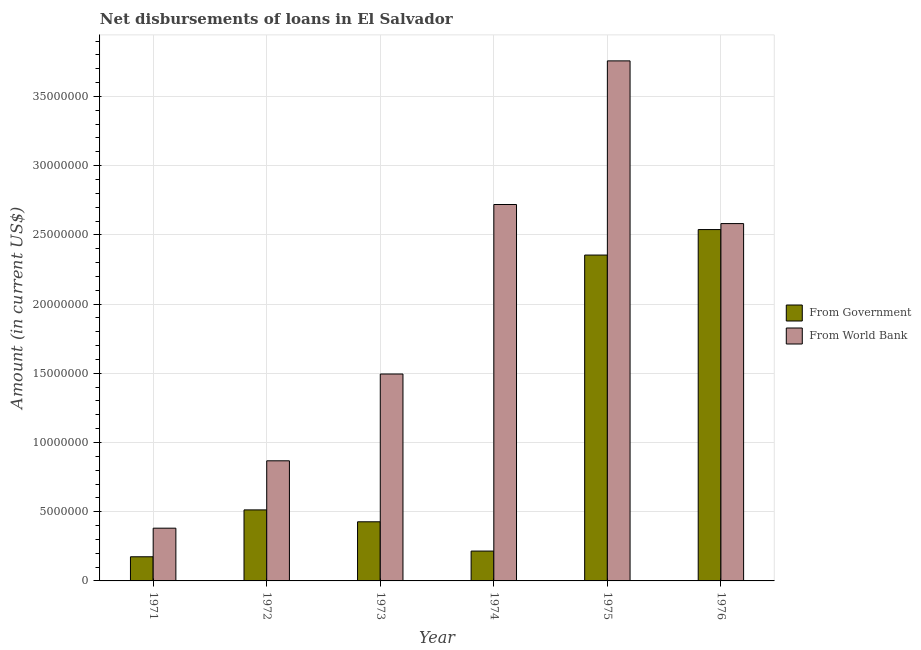How many groups of bars are there?
Offer a very short reply. 6. Are the number of bars per tick equal to the number of legend labels?
Provide a short and direct response. Yes. Are the number of bars on each tick of the X-axis equal?
Offer a terse response. Yes. What is the label of the 6th group of bars from the left?
Ensure brevity in your answer.  1976. What is the net disbursements of loan from government in 1974?
Offer a very short reply. 2.16e+06. Across all years, what is the maximum net disbursements of loan from world bank?
Give a very brief answer. 3.76e+07. Across all years, what is the minimum net disbursements of loan from world bank?
Your answer should be compact. 3.81e+06. In which year was the net disbursements of loan from government maximum?
Give a very brief answer. 1976. What is the total net disbursements of loan from government in the graph?
Give a very brief answer. 6.22e+07. What is the difference between the net disbursements of loan from world bank in 1972 and that in 1975?
Offer a terse response. -2.89e+07. What is the difference between the net disbursements of loan from world bank in 1971 and the net disbursements of loan from government in 1972?
Ensure brevity in your answer.  -4.87e+06. What is the average net disbursements of loan from government per year?
Your answer should be very brief. 1.04e+07. In how many years, is the net disbursements of loan from government greater than 7000000 US$?
Offer a very short reply. 2. What is the ratio of the net disbursements of loan from government in 1975 to that in 1976?
Provide a short and direct response. 0.93. Is the difference between the net disbursements of loan from government in 1974 and 1975 greater than the difference between the net disbursements of loan from world bank in 1974 and 1975?
Keep it short and to the point. No. What is the difference between the highest and the second highest net disbursements of loan from world bank?
Give a very brief answer. 1.04e+07. What is the difference between the highest and the lowest net disbursements of loan from government?
Provide a short and direct response. 2.36e+07. Is the sum of the net disbursements of loan from government in 1973 and 1975 greater than the maximum net disbursements of loan from world bank across all years?
Your answer should be very brief. Yes. What does the 1st bar from the left in 1976 represents?
Provide a succinct answer. From Government. What does the 2nd bar from the right in 1972 represents?
Keep it short and to the point. From Government. How many bars are there?
Keep it short and to the point. 12. Are all the bars in the graph horizontal?
Your answer should be very brief. No. Are the values on the major ticks of Y-axis written in scientific E-notation?
Offer a terse response. No. Does the graph contain any zero values?
Make the answer very short. No. Does the graph contain grids?
Your response must be concise. Yes. How many legend labels are there?
Provide a succinct answer. 2. What is the title of the graph?
Your answer should be compact. Net disbursements of loans in El Salvador. What is the label or title of the X-axis?
Your answer should be compact. Year. What is the Amount (in current US$) of From Government in 1971?
Provide a succinct answer. 1.74e+06. What is the Amount (in current US$) in From World Bank in 1971?
Offer a terse response. 3.81e+06. What is the Amount (in current US$) of From Government in 1972?
Your answer should be compact. 5.13e+06. What is the Amount (in current US$) of From World Bank in 1972?
Keep it short and to the point. 8.68e+06. What is the Amount (in current US$) of From Government in 1973?
Make the answer very short. 4.27e+06. What is the Amount (in current US$) of From World Bank in 1973?
Offer a very short reply. 1.49e+07. What is the Amount (in current US$) in From Government in 1974?
Your answer should be compact. 2.16e+06. What is the Amount (in current US$) in From World Bank in 1974?
Your answer should be compact. 2.72e+07. What is the Amount (in current US$) in From Government in 1975?
Your response must be concise. 2.35e+07. What is the Amount (in current US$) in From World Bank in 1975?
Ensure brevity in your answer.  3.76e+07. What is the Amount (in current US$) of From Government in 1976?
Make the answer very short. 2.54e+07. What is the Amount (in current US$) in From World Bank in 1976?
Keep it short and to the point. 2.58e+07. Across all years, what is the maximum Amount (in current US$) in From Government?
Your answer should be compact. 2.54e+07. Across all years, what is the maximum Amount (in current US$) in From World Bank?
Your answer should be very brief. 3.76e+07. Across all years, what is the minimum Amount (in current US$) in From Government?
Your answer should be compact. 1.74e+06. Across all years, what is the minimum Amount (in current US$) of From World Bank?
Make the answer very short. 3.81e+06. What is the total Amount (in current US$) in From Government in the graph?
Give a very brief answer. 6.22e+07. What is the total Amount (in current US$) of From World Bank in the graph?
Your response must be concise. 1.18e+08. What is the difference between the Amount (in current US$) in From Government in 1971 and that in 1972?
Provide a succinct answer. -3.39e+06. What is the difference between the Amount (in current US$) in From World Bank in 1971 and that in 1972?
Keep it short and to the point. -4.87e+06. What is the difference between the Amount (in current US$) in From Government in 1971 and that in 1973?
Your answer should be compact. -2.53e+06. What is the difference between the Amount (in current US$) in From World Bank in 1971 and that in 1973?
Ensure brevity in your answer.  -1.11e+07. What is the difference between the Amount (in current US$) of From Government in 1971 and that in 1974?
Ensure brevity in your answer.  -4.11e+05. What is the difference between the Amount (in current US$) of From World Bank in 1971 and that in 1974?
Make the answer very short. -2.34e+07. What is the difference between the Amount (in current US$) of From Government in 1971 and that in 1975?
Make the answer very short. -2.18e+07. What is the difference between the Amount (in current US$) in From World Bank in 1971 and that in 1975?
Make the answer very short. -3.38e+07. What is the difference between the Amount (in current US$) in From Government in 1971 and that in 1976?
Your answer should be very brief. -2.36e+07. What is the difference between the Amount (in current US$) of From World Bank in 1971 and that in 1976?
Give a very brief answer. -2.20e+07. What is the difference between the Amount (in current US$) in From Government in 1972 and that in 1973?
Provide a succinct answer. 8.59e+05. What is the difference between the Amount (in current US$) in From World Bank in 1972 and that in 1973?
Offer a very short reply. -6.27e+06. What is the difference between the Amount (in current US$) in From Government in 1972 and that in 1974?
Keep it short and to the point. 2.98e+06. What is the difference between the Amount (in current US$) in From World Bank in 1972 and that in 1974?
Give a very brief answer. -1.85e+07. What is the difference between the Amount (in current US$) in From Government in 1972 and that in 1975?
Keep it short and to the point. -1.84e+07. What is the difference between the Amount (in current US$) of From World Bank in 1972 and that in 1975?
Provide a short and direct response. -2.89e+07. What is the difference between the Amount (in current US$) in From Government in 1972 and that in 1976?
Your answer should be compact. -2.03e+07. What is the difference between the Amount (in current US$) in From World Bank in 1972 and that in 1976?
Ensure brevity in your answer.  -1.71e+07. What is the difference between the Amount (in current US$) of From Government in 1973 and that in 1974?
Keep it short and to the point. 2.12e+06. What is the difference between the Amount (in current US$) of From World Bank in 1973 and that in 1974?
Your response must be concise. -1.22e+07. What is the difference between the Amount (in current US$) of From Government in 1973 and that in 1975?
Offer a very short reply. -1.93e+07. What is the difference between the Amount (in current US$) of From World Bank in 1973 and that in 1975?
Your answer should be very brief. -2.26e+07. What is the difference between the Amount (in current US$) in From Government in 1973 and that in 1976?
Give a very brief answer. -2.11e+07. What is the difference between the Amount (in current US$) in From World Bank in 1973 and that in 1976?
Keep it short and to the point. -1.09e+07. What is the difference between the Amount (in current US$) in From Government in 1974 and that in 1975?
Keep it short and to the point. -2.14e+07. What is the difference between the Amount (in current US$) of From World Bank in 1974 and that in 1975?
Your response must be concise. -1.04e+07. What is the difference between the Amount (in current US$) of From Government in 1974 and that in 1976?
Give a very brief answer. -2.32e+07. What is the difference between the Amount (in current US$) in From World Bank in 1974 and that in 1976?
Offer a very short reply. 1.38e+06. What is the difference between the Amount (in current US$) of From Government in 1975 and that in 1976?
Give a very brief answer. -1.84e+06. What is the difference between the Amount (in current US$) of From World Bank in 1975 and that in 1976?
Keep it short and to the point. 1.18e+07. What is the difference between the Amount (in current US$) in From Government in 1971 and the Amount (in current US$) in From World Bank in 1972?
Give a very brief answer. -6.93e+06. What is the difference between the Amount (in current US$) of From Government in 1971 and the Amount (in current US$) of From World Bank in 1973?
Your response must be concise. -1.32e+07. What is the difference between the Amount (in current US$) of From Government in 1971 and the Amount (in current US$) of From World Bank in 1974?
Provide a succinct answer. -2.54e+07. What is the difference between the Amount (in current US$) in From Government in 1971 and the Amount (in current US$) in From World Bank in 1975?
Offer a terse response. -3.58e+07. What is the difference between the Amount (in current US$) in From Government in 1971 and the Amount (in current US$) in From World Bank in 1976?
Keep it short and to the point. -2.41e+07. What is the difference between the Amount (in current US$) of From Government in 1972 and the Amount (in current US$) of From World Bank in 1973?
Give a very brief answer. -9.82e+06. What is the difference between the Amount (in current US$) of From Government in 1972 and the Amount (in current US$) of From World Bank in 1974?
Ensure brevity in your answer.  -2.21e+07. What is the difference between the Amount (in current US$) in From Government in 1972 and the Amount (in current US$) in From World Bank in 1975?
Keep it short and to the point. -3.24e+07. What is the difference between the Amount (in current US$) of From Government in 1972 and the Amount (in current US$) of From World Bank in 1976?
Your response must be concise. -2.07e+07. What is the difference between the Amount (in current US$) of From Government in 1973 and the Amount (in current US$) of From World Bank in 1974?
Your response must be concise. -2.29e+07. What is the difference between the Amount (in current US$) in From Government in 1973 and the Amount (in current US$) in From World Bank in 1975?
Give a very brief answer. -3.33e+07. What is the difference between the Amount (in current US$) in From Government in 1973 and the Amount (in current US$) in From World Bank in 1976?
Provide a short and direct response. -2.15e+07. What is the difference between the Amount (in current US$) of From Government in 1974 and the Amount (in current US$) of From World Bank in 1975?
Give a very brief answer. -3.54e+07. What is the difference between the Amount (in current US$) in From Government in 1974 and the Amount (in current US$) in From World Bank in 1976?
Your response must be concise. -2.37e+07. What is the difference between the Amount (in current US$) of From Government in 1975 and the Amount (in current US$) of From World Bank in 1976?
Keep it short and to the point. -2.27e+06. What is the average Amount (in current US$) of From Government per year?
Give a very brief answer. 1.04e+07. What is the average Amount (in current US$) in From World Bank per year?
Your response must be concise. 1.97e+07. In the year 1971, what is the difference between the Amount (in current US$) in From Government and Amount (in current US$) in From World Bank?
Give a very brief answer. -2.06e+06. In the year 1972, what is the difference between the Amount (in current US$) of From Government and Amount (in current US$) of From World Bank?
Offer a very short reply. -3.55e+06. In the year 1973, what is the difference between the Amount (in current US$) of From Government and Amount (in current US$) of From World Bank?
Offer a terse response. -1.07e+07. In the year 1974, what is the difference between the Amount (in current US$) of From Government and Amount (in current US$) of From World Bank?
Your answer should be compact. -2.50e+07. In the year 1975, what is the difference between the Amount (in current US$) in From Government and Amount (in current US$) in From World Bank?
Your answer should be compact. -1.40e+07. In the year 1976, what is the difference between the Amount (in current US$) in From Government and Amount (in current US$) in From World Bank?
Give a very brief answer. -4.33e+05. What is the ratio of the Amount (in current US$) in From Government in 1971 to that in 1972?
Offer a very short reply. 0.34. What is the ratio of the Amount (in current US$) in From World Bank in 1971 to that in 1972?
Offer a terse response. 0.44. What is the ratio of the Amount (in current US$) in From Government in 1971 to that in 1973?
Give a very brief answer. 0.41. What is the ratio of the Amount (in current US$) of From World Bank in 1971 to that in 1973?
Provide a succinct answer. 0.25. What is the ratio of the Amount (in current US$) of From Government in 1971 to that in 1974?
Offer a very short reply. 0.81. What is the ratio of the Amount (in current US$) in From World Bank in 1971 to that in 1974?
Make the answer very short. 0.14. What is the ratio of the Amount (in current US$) in From Government in 1971 to that in 1975?
Provide a short and direct response. 0.07. What is the ratio of the Amount (in current US$) of From World Bank in 1971 to that in 1975?
Provide a succinct answer. 0.1. What is the ratio of the Amount (in current US$) in From Government in 1971 to that in 1976?
Your response must be concise. 0.07. What is the ratio of the Amount (in current US$) of From World Bank in 1971 to that in 1976?
Make the answer very short. 0.15. What is the ratio of the Amount (in current US$) in From Government in 1972 to that in 1973?
Make the answer very short. 1.2. What is the ratio of the Amount (in current US$) of From World Bank in 1972 to that in 1973?
Provide a succinct answer. 0.58. What is the ratio of the Amount (in current US$) in From Government in 1972 to that in 1974?
Offer a terse response. 2.38. What is the ratio of the Amount (in current US$) of From World Bank in 1972 to that in 1974?
Offer a very short reply. 0.32. What is the ratio of the Amount (in current US$) in From Government in 1972 to that in 1975?
Offer a very short reply. 0.22. What is the ratio of the Amount (in current US$) in From World Bank in 1972 to that in 1975?
Offer a terse response. 0.23. What is the ratio of the Amount (in current US$) in From Government in 1972 to that in 1976?
Give a very brief answer. 0.2. What is the ratio of the Amount (in current US$) of From World Bank in 1972 to that in 1976?
Your answer should be compact. 0.34. What is the ratio of the Amount (in current US$) of From Government in 1973 to that in 1974?
Provide a short and direct response. 1.98. What is the ratio of the Amount (in current US$) in From World Bank in 1973 to that in 1974?
Offer a terse response. 0.55. What is the ratio of the Amount (in current US$) of From Government in 1973 to that in 1975?
Offer a very short reply. 0.18. What is the ratio of the Amount (in current US$) of From World Bank in 1973 to that in 1975?
Provide a succinct answer. 0.4. What is the ratio of the Amount (in current US$) in From Government in 1973 to that in 1976?
Provide a succinct answer. 0.17. What is the ratio of the Amount (in current US$) in From World Bank in 1973 to that in 1976?
Make the answer very short. 0.58. What is the ratio of the Amount (in current US$) in From Government in 1974 to that in 1975?
Your answer should be very brief. 0.09. What is the ratio of the Amount (in current US$) of From World Bank in 1974 to that in 1975?
Provide a short and direct response. 0.72. What is the ratio of the Amount (in current US$) in From Government in 1974 to that in 1976?
Your answer should be compact. 0.08. What is the ratio of the Amount (in current US$) in From World Bank in 1974 to that in 1976?
Provide a short and direct response. 1.05. What is the ratio of the Amount (in current US$) of From Government in 1975 to that in 1976?
Give a very brief answer. 0.93. What is the ratio of the Amount (in current US$) in From World Bank in 1975 to that in 1976?
Keep it short and to the point. 1.46. What is the difference between the highest and the second highest Amount (in current US$) of From Government?
Provide a short and direct response. 1.84e+06. What is the difference between the highest and the second highest Amount (in current US$) in From World Bank?
Your response must be concise. 1.04e+07. What is the difference between the highest and the lowest Amount (in current US$) of From Government?
Your answer should be very brief. 2.36e+07. What is the difference between the highest and the lowest Amount (in current US$) in From World Bank?
Provide a short and direct response. 3.38e+07. 